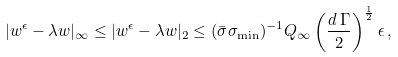Convert formula to latex. <formula><loc_0><loc_0><loc_500><loc_500>| w ^ { \epsilon } - \lambda w | _ { \infty } \leq | w ^ { \epsilon } - \lambda w | _ { 2 } \leq ( \bar { \sigma } \sigma _ { \min } ) ^ { - 1 } Q _ { \infty } \left ( \frac { d \, \Gamma } { 2 } \right ) ^ { \frac { 1 } { 2 } } \epsilon \, ,</formula> 